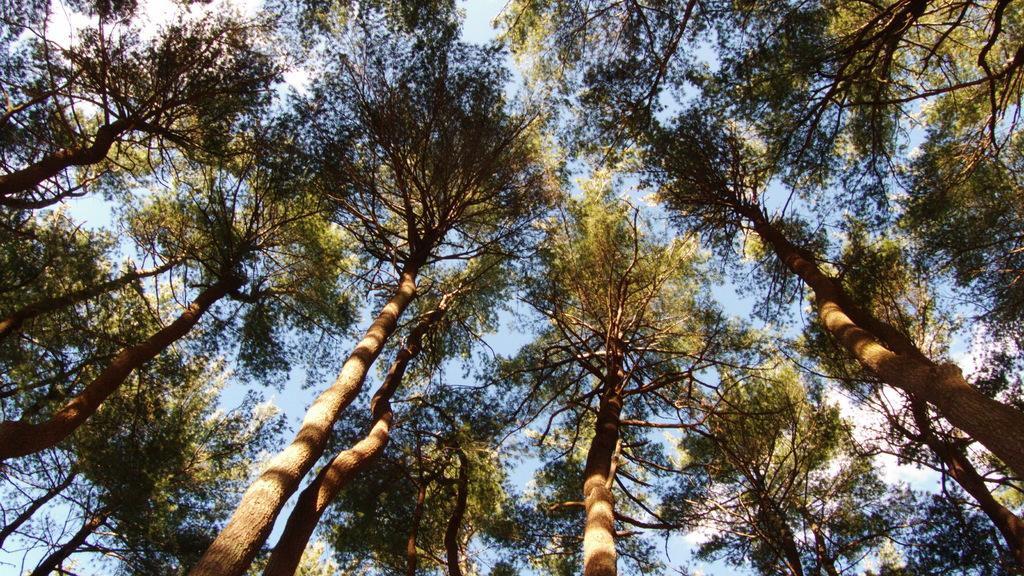What type of vegetation can be seen in the image? There are trees in the image. What is visible at the top of the image? The sky is visible at the top of the image. Where is the throne located in the image? There is no throne present in the image. What type of shop can be seen in the image? There is no shop present in the image. 